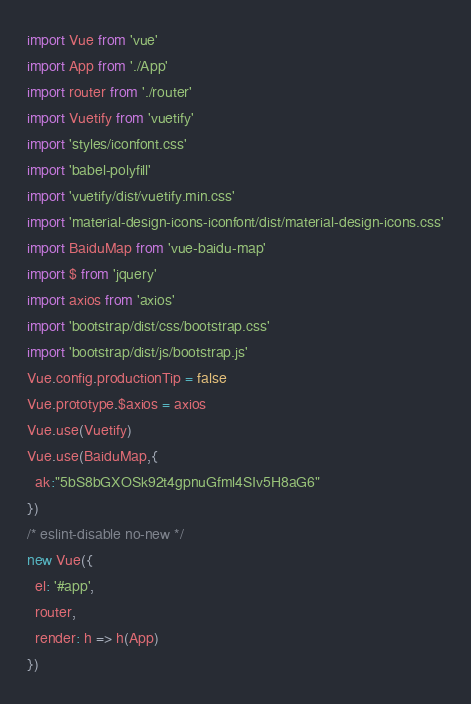Convert code to text. <code><loc_0><loc_0><loc_500><loc_500><_JavaScript_>import Vue from 'vue'
import App from './App'
import router from './router'
import Vuetify from 'vuetify'
import 'styles/iconfont.css'
import 'babel-polyfill'
import 'vuetify/dist/vuetify.min.css'
import 'material-design-icons-iconfont/dist/material-design-icons.css'
import BaiduMap from 'vue-baidu-map'
import $ from 'jquery'
import axios from 'axios'
import 'bootstrap/dist/css/bootstrap.css'
import 'bootstrap/dist/js/bootstrap.js'
Vue.config.productionTip = false
Vue.prototype.$axios = axios
Vue.use(Vuetify)
Vue.use(BaiduMap,{
  ak:"5bS8bGXOSk92t4gpnuGfml4SIv5H8aG6"
})
/* eslint-disable no-new */
new Vue({
  el: '#app',
  router,
  render: h => h(App)
})
</code> 